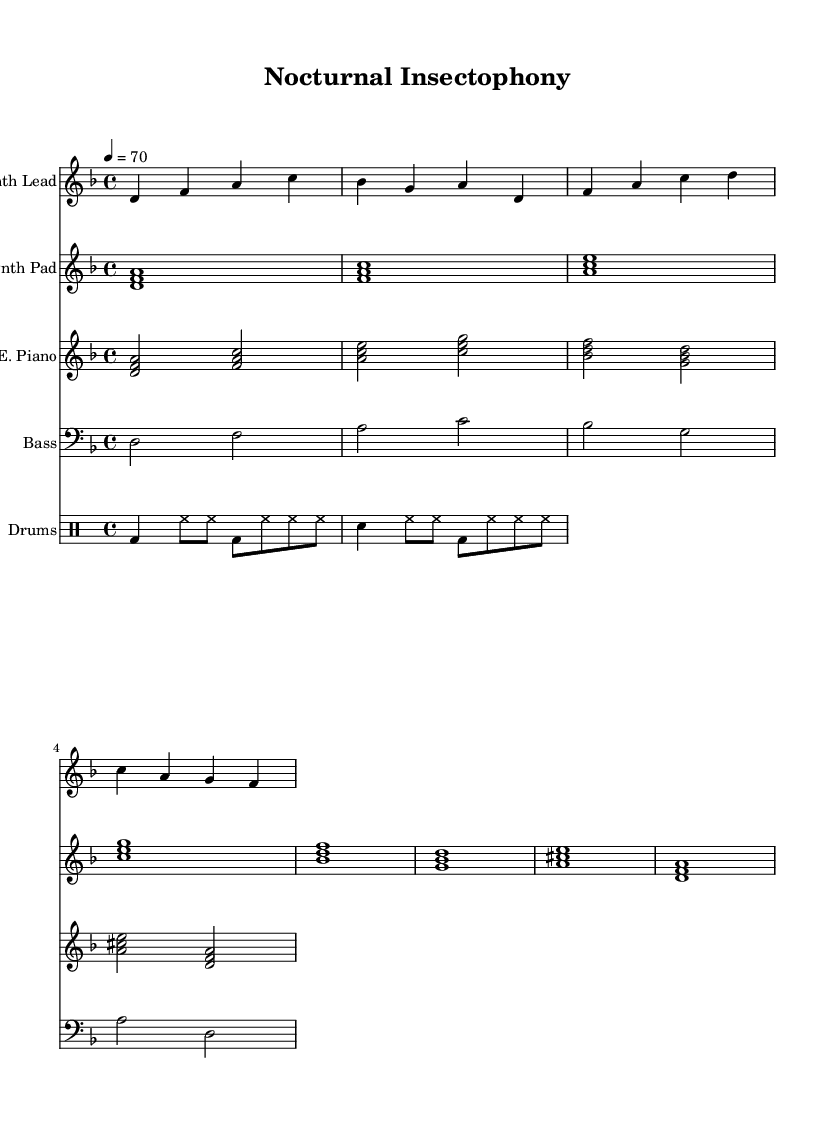What is the key signature of this music? The key signature is indicated at the beginning of the staff. In this case, it shows two flats (B and E), which signifies D minor.
Answer: D minor What is the time signature used in this piece? The time signature is found just after the key signature. Here, it is 4/4, meaning there are four beats in each measure.
Answer: 4/4 What is the tempo marking for this music? The tempo marking is written as "4 = 70," which means there are 70 beats per minute.
Answer: 70 How many measures does the synth lead part have? By counting the grouped notes, the synth lead part consists of 4 measures corresponding to the rhythms presented.
Answer: 4 What is the main instrument featured in the drum section? The drum section consists of bass drum, snare drum, and hi-hat patterns, highlighting the bass drum as a key foreground element.
Answer: Bass drum Which two instruments are using the same chord structure? Both the synth pad and electric piano use the same chord progression, displaying the same set of harmonies in their measures.
Answer: Synth pad and electric piano How many notes are played simultaneously in the synth pad part? The synth pad section incorporates chords, which are indicated by the presence of multiple notes that are played together across measures. Each chord in the synth pad displays three notes simultaneously.
Answer: Three notes 